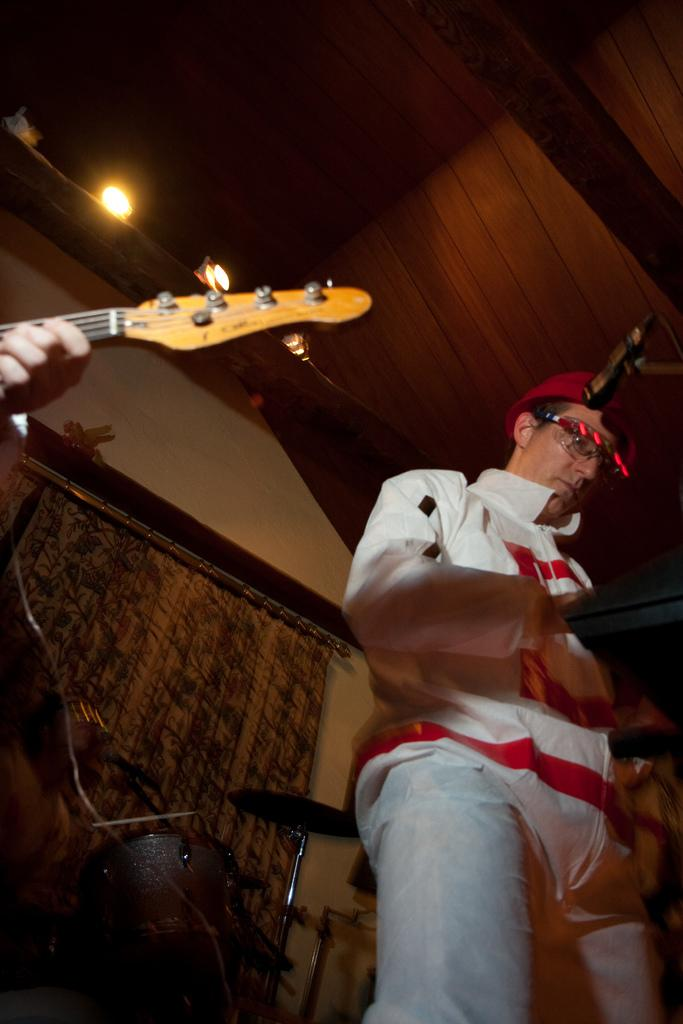What are the two people in the image doing? The two people in the image are playing musical instruments. Can you describe the musical instruments in the image? There are two musical instruments being played by the people, and additional musical instruments can be seen in the background. What is in the background of the image? There is a curtain in the background of the image. What is the source of light in the image? There is a light at the top of the image. What type of celery is being used as a percussion instrument in the image? There is no celery present in the image, and it is not being used as a percussion instrument. 